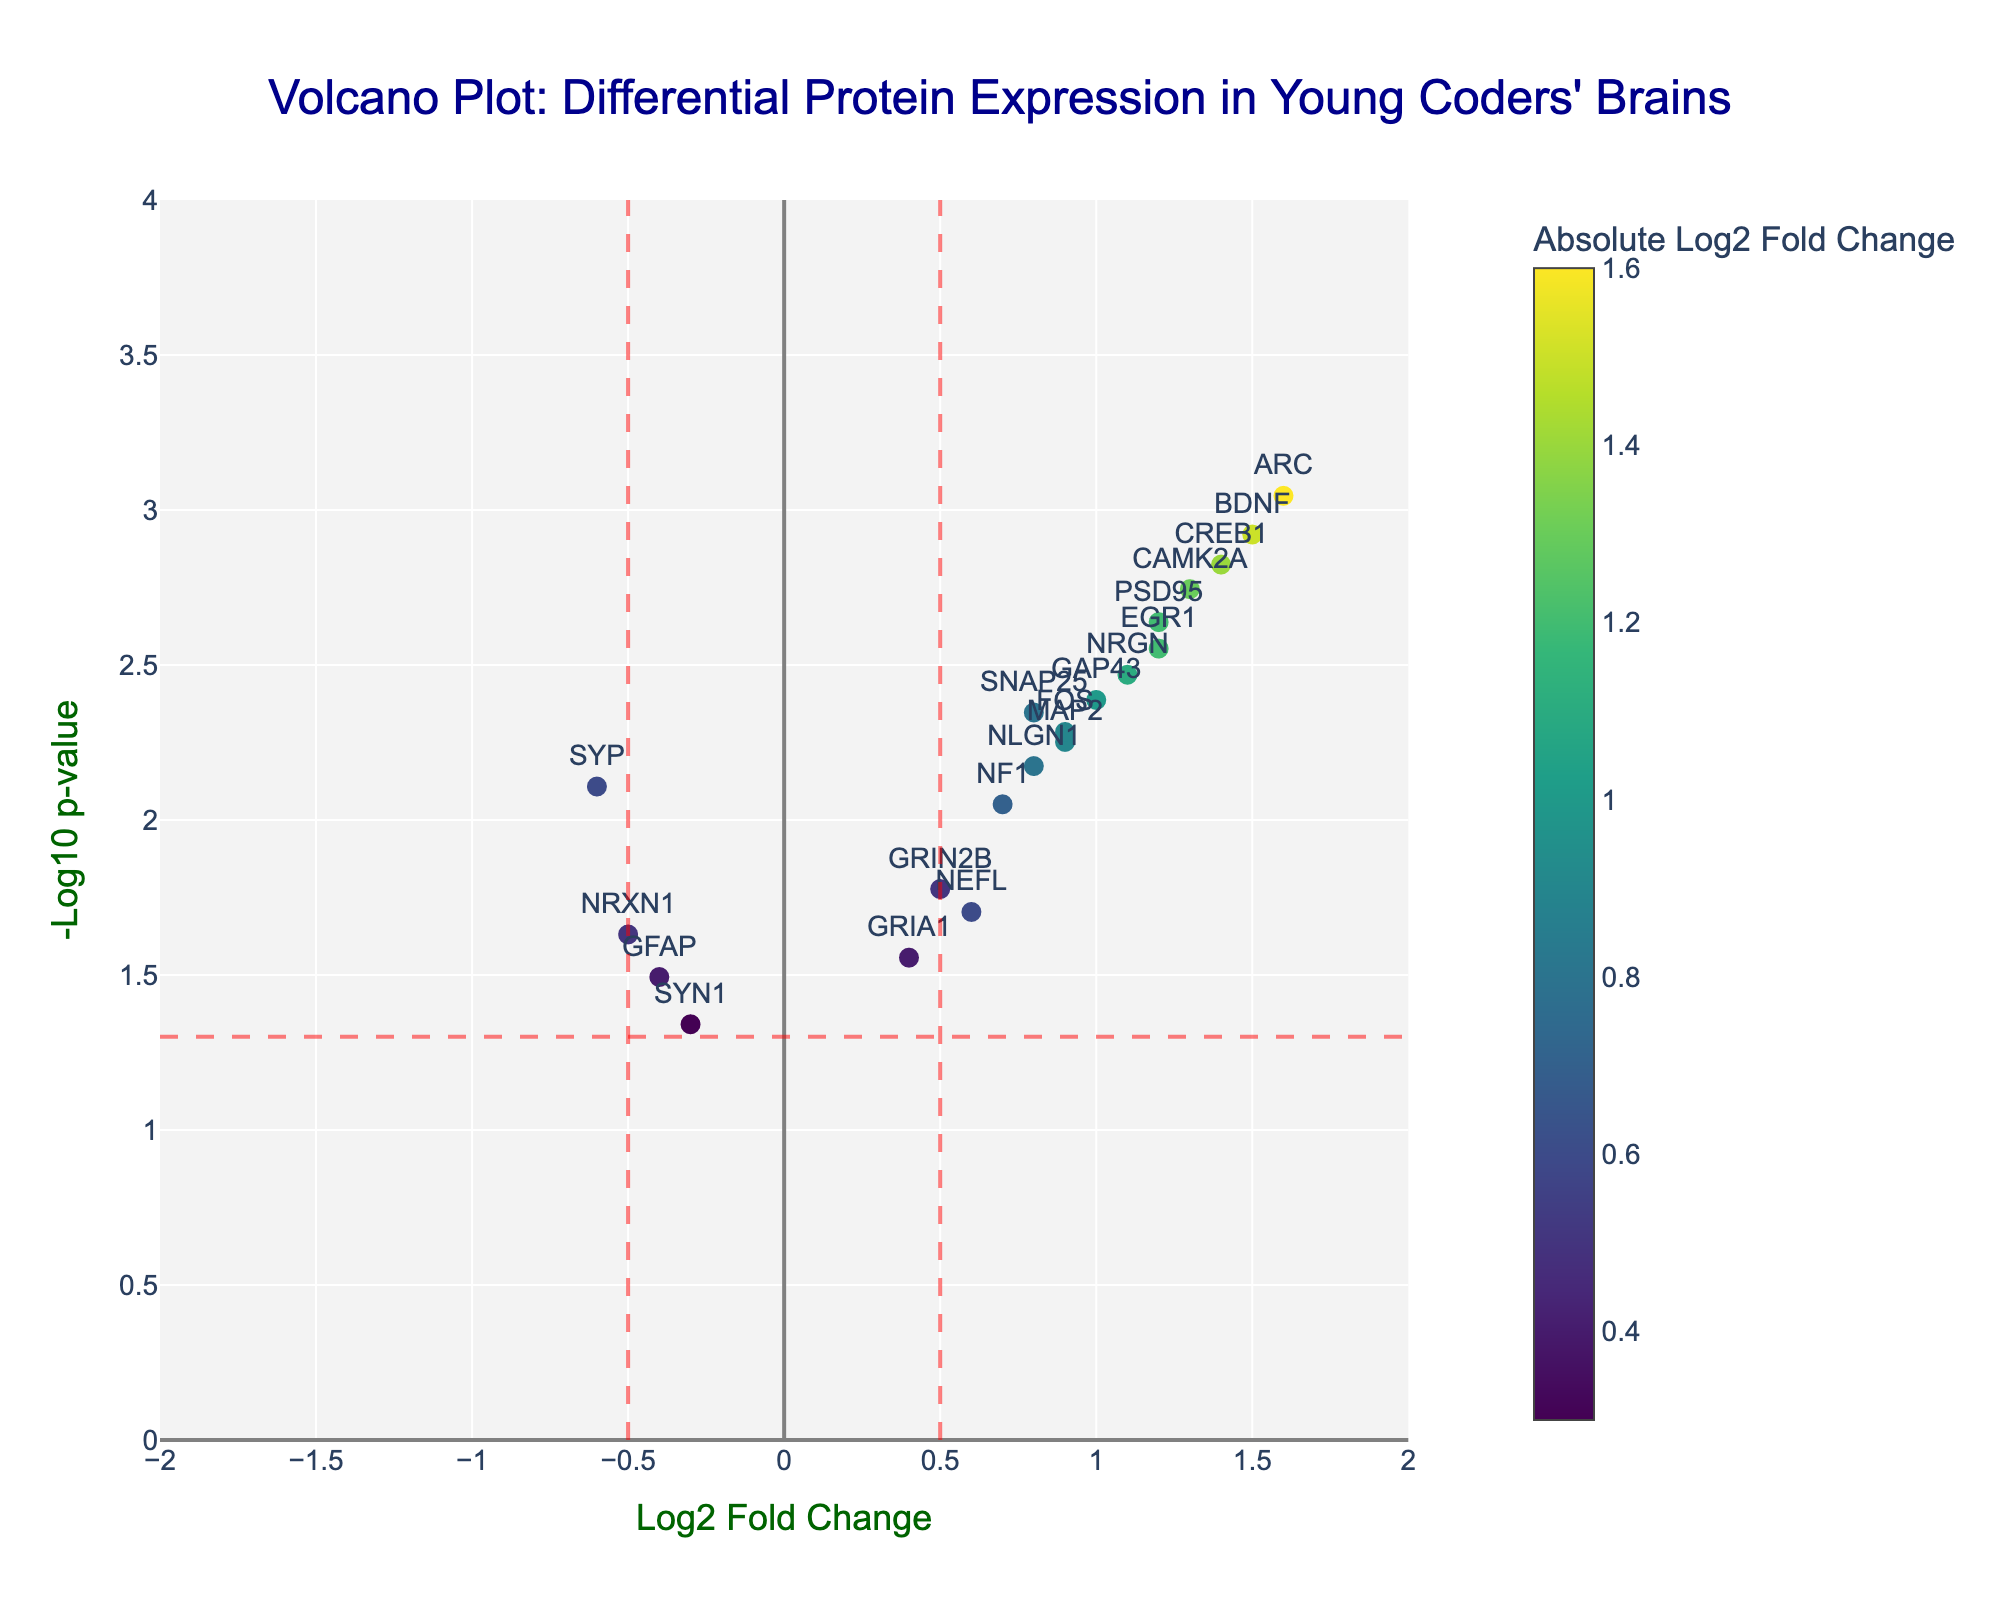What is the title of the plot? The title of the plot is located at the top center of the figure. It is usually larger and more prominent than other text elements. The title provides a summary of what the plot represents.
Answer: Volcano Plot: Differential Protein Expression in Young Coders' Brains How many proteins have a p-value less than 0.01? To find this, look at the y-axis, which represents the -log10 of the p-value. A p-value of 0.01 corresponds to -log10(0.01) = 2. Therefore, count the number of data points above the y-axis value of 2.
Answer: 7 Which protein has the highest Log2 Fold Change? By examining the x-axis (Log2 Fold Change), find the data point farthest to the right. The protein name next to this data point indicates the protein with the highest Log2 Fold Change.
Answer: ARC What are the fold change and p-value thresholds? The plot includes horizontal and vertical dashed lines which represent these thresholds. The vertical lines indicate the fold change threshold, and the horizontal line indicates the p-value threshold.
Answer: 0.5 for fold change, 0.05 for p-value Which protein has the highest -Log10 p-value? To determine this, find the data point that is the highest on the y-axis, which represents the -Log10 p-value. The corresponding protein name next to this point indicates the protein with the highest -Log10 p-value.
Answer: ARC How many proteins have a negative Log2 Fold Change? Look at the x-axis values to the left of zero. Count the number of data points positioned to the left of the zero mark to determine how many proteins have a negative Log2 Fold Change.
Answer: 4 Which protein has a Log2 Fold Change between 0.8 and 1.0 and a p-value less than 0.01? First, identify the data points where the x-axis value (Log2 Fold Change) lies between 0.8 and 1.0 and then check if their y-axis value lies above approximately 2 (-log10(0.01)). From these points, identify the corresponding protein names.
Answer: NRGN and GAP43 Which protein has the highest Log2 Fold Change and is not statistically significant? Statistically significant points are those above the horizontal threshold line. To find the highest Log2 Fold Change that is below this line, determine the highest x-axis value that is below the corresponding -log10(p-value) threshold line.
Answer: GRIN2B What is the color used to indicate the absolute Log2 Fold Change in the plot? The color scale (Viridis) represents absolute Log2 Fold Change values of the data points. A color bar titled "Absolute Log2 Fold Change" is usually displayed beside the plot indicating the color ranges.
Answer: A gradient from purple to yellow Which proteins have both significant and positive Log2 Fold Change? Proteins that meet this criterion will have data points positioned above the horizontal threshold line (significant) and to the right of the vertical threshold line (positive Log2 Fold Change). Identify and list these protein names.
Answer: BDNF, PSD95, CAMK2A, GAP43, CREB1, ARC, EGR1 